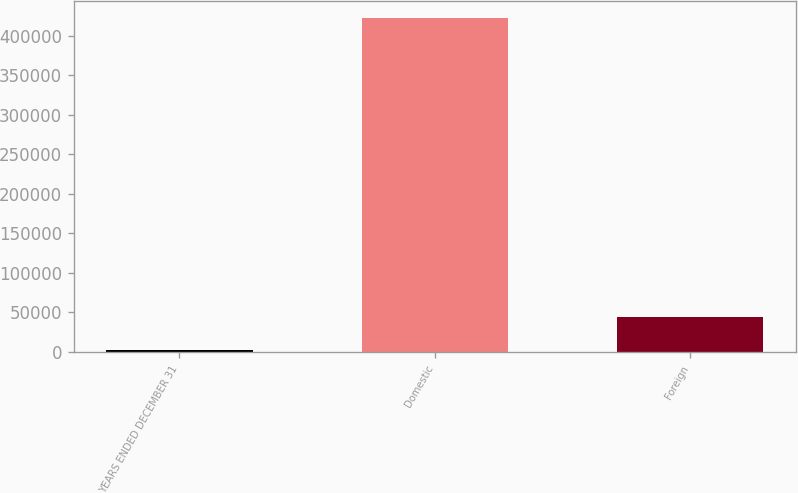<chart> <loc_0><loc_0><loc_500><loc_500><bar_chart><fcel>YEARS ENDED DECEMBER 31<fcel>Domestic<fcel>Foreign<nl><fcel>2006<fcel>423312<fcel>44136.6<nl></chart> 